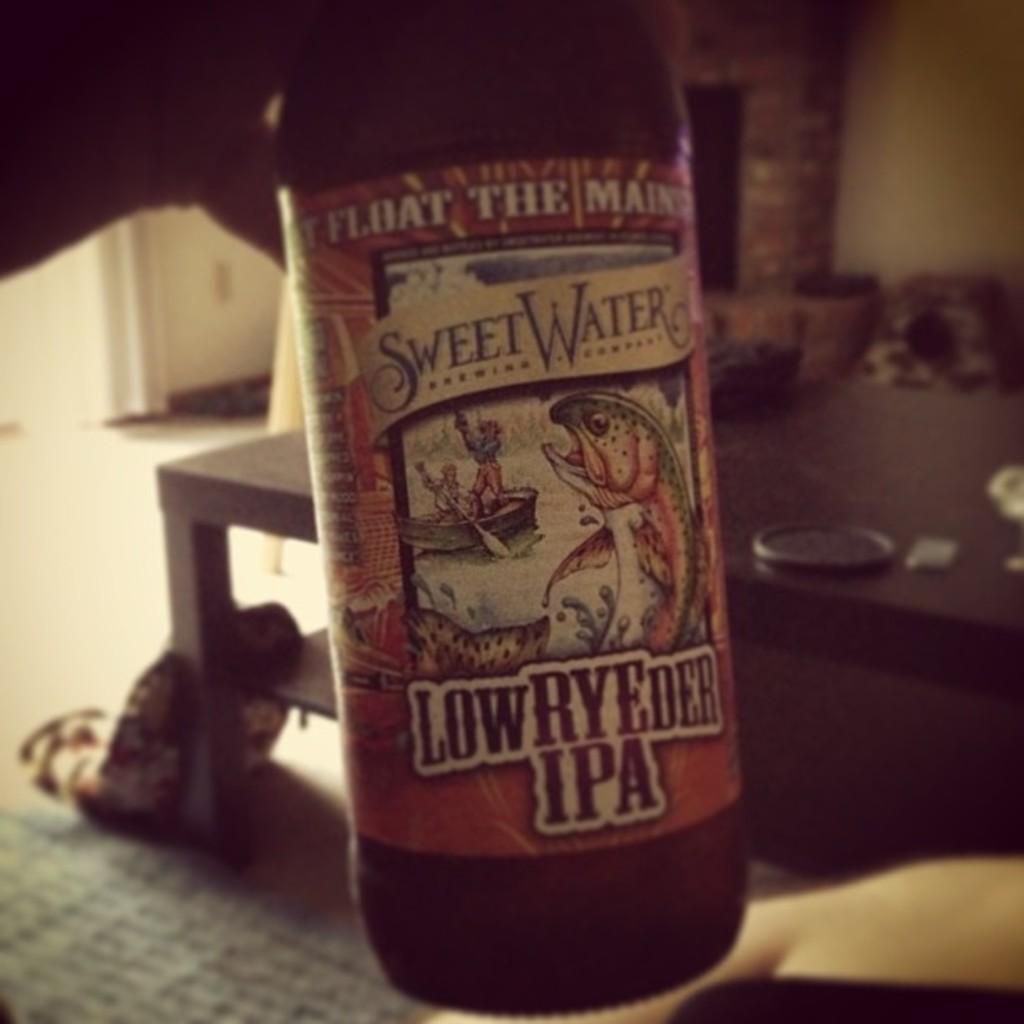<image>
Share a concise interpretation of the image provided. A bottle has a Sweet Water label on it with a picture of a boat. 